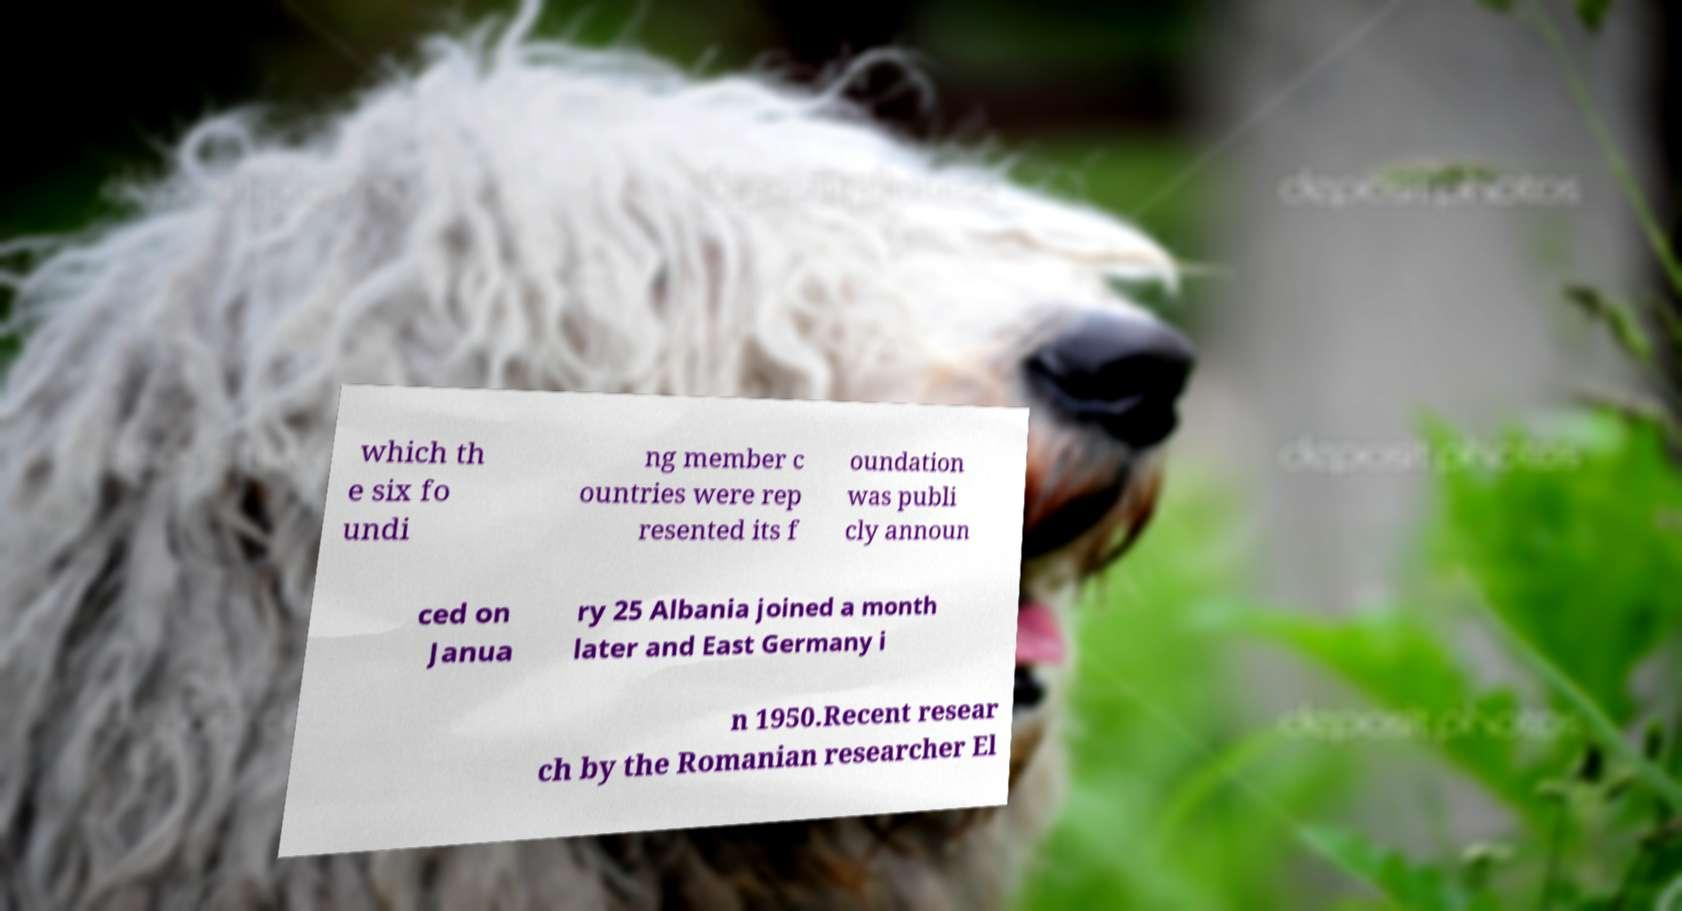I need the written content from this picture converted into text. Can you do that? which th e six fo undi ng member c ountries were rep resented its f oundation was publi cly announ ced on Janua ry 25 Albania joined a month later and East Germany i n 1950.Recent resear ch by the Romanian researcher El 